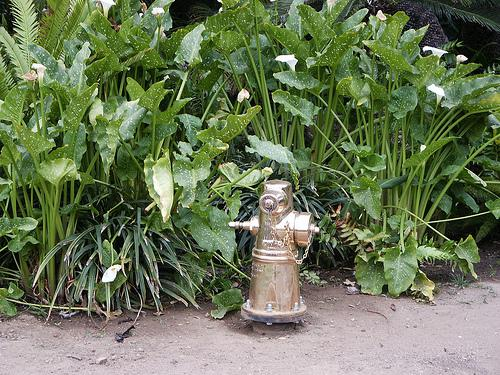Question: what color is the fire hydrant?
Choices:
A. Red.
B. Green.
C. Gold.
D. Blue.
Answer with the letter. Answer: C Question: what is the ground made of?
Choices:
A. Grass.
B. Wood.
C. Dirt.
D. Carpet.
Answer with the letter. Answer: C Question: when does this take place, in the day or at night?
Choices:
A. Night.
B. Christmas.
C. Daytime.
D. Halloween.
Answer with the letter. Answer: C 